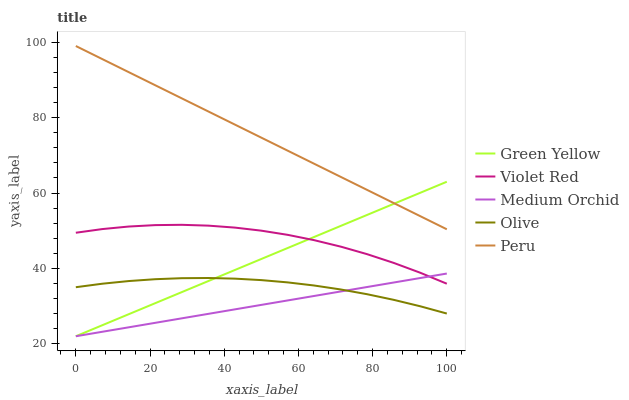Does Medium Orchid have the minimum area under the curve?
Answer yes or no. Yes. Does Peru have the maximum area under the curve?
Answer yes or no. Yes. Does Violet Red have the minimum area under the curve?
Answer yes or no. No. Does Violet Red have the maximum area under the curve?
Answer yes or no. No. Is Green Yellow the smoothest?
Answer yes or no. Yes. Is Violet Red the roughest?
Answer yes or no. Yes. Is Violet Red the smoothest?
Answer yes or no. No. Is Green Yellow the roughest?
Answer yes or no. No. Does Green Yellow have the lowest value?
Answer yes or no. Yes. Does Violet Red have the lowest value?
Answer yes or no. No. Does Peru have the highest value?
Answer yes or no. Yes. Does Violet Red have the highest value?
Answer yes or no. No. Is Olive less than Peru?
Answer yes or no. Yes. Is Peru greater than Medium Orchid?
Answer yes or no. Yes. Does Green Yellow intersect Medium Orchid?
Answer yes or no. Yes. Is Green Yellow less than Medium Orchid?
Answer yes or no. No. Is Green Yellow greater than Medium Orchid?
Answer yes or no. No. Does Olive intersect Peru?
Answer yes or no. No. 